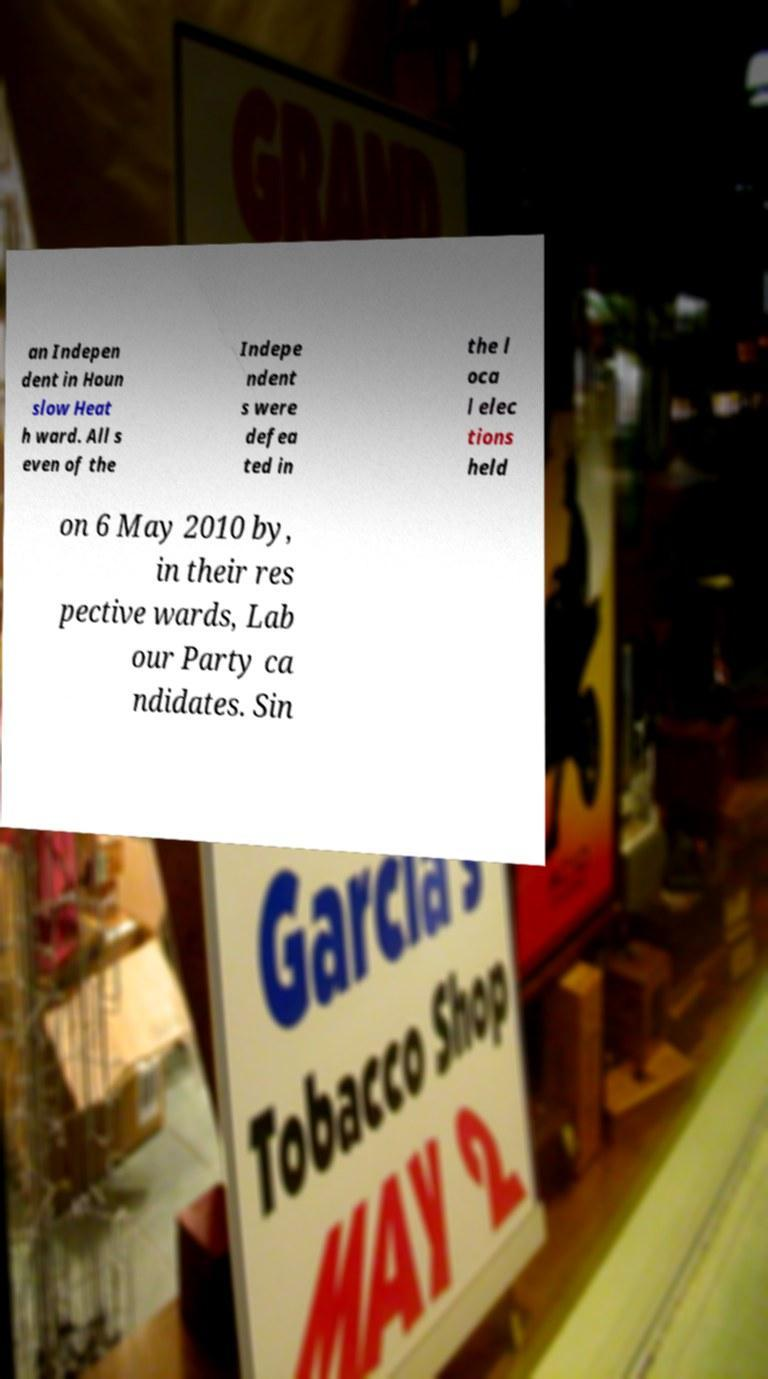Can you read and provide the text displayed in the image?This photo seems to have some interesting text. Can you extract and type it out for me? an Indepen dent in Houn slow Heat h ward. All s even of the Indepe ndent s were defea ted in the l oca l elec tions held on 6 May 2010 by, in their res pective wards, Lab our Party ca ndidates. Sin 